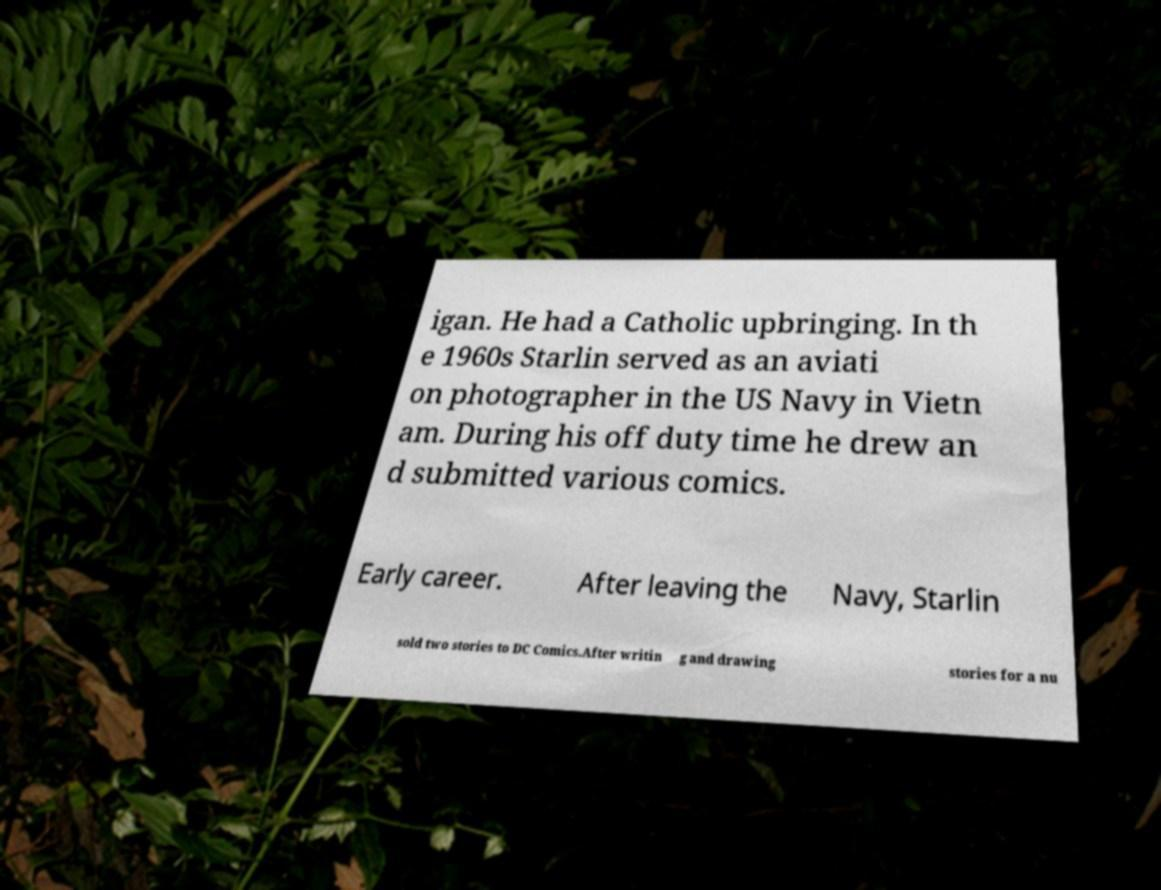Can you read and provide the text displayed in the image?This photo seems to have some interesting text. Can you extract and type it out for me? igan. He had a Catholic upbringing. In th e 1960s Starlin served as an aviati on photographer in the US Navy in Vietn am. During his off duty time he drew an d submitted various comics. Early career. After leaving the Navy, Starlin sold two stories to DC Comics.After writin g and drawing stories for a nu 